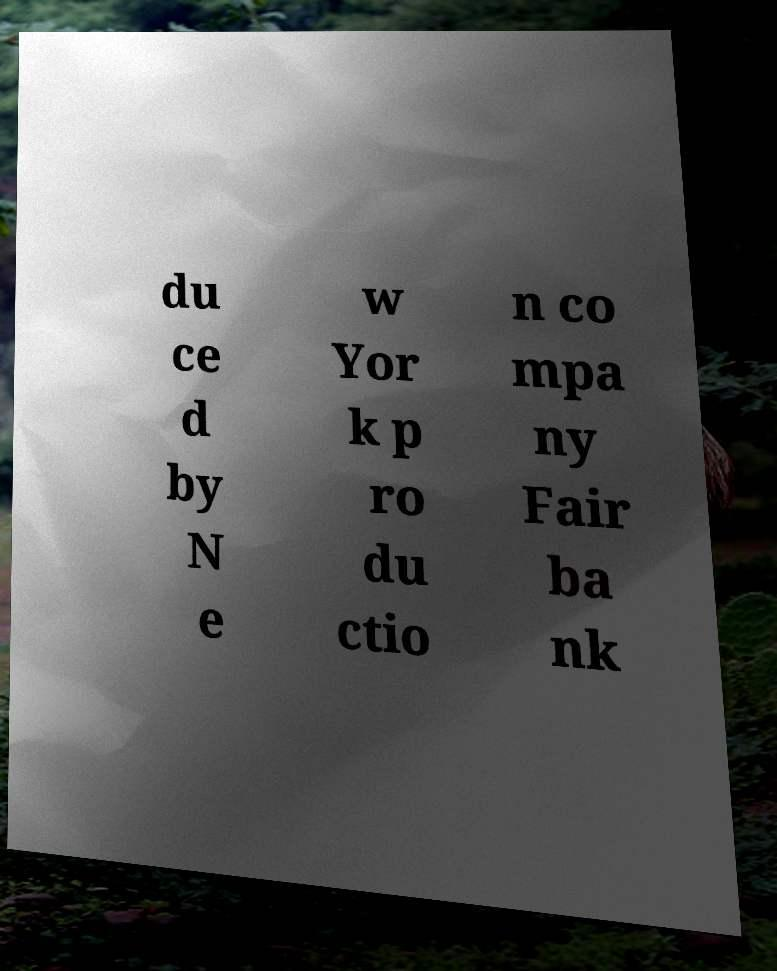What messages or text are displayed in this image? I need them in a readable, typed format. du ce d by N e w Yor k p ro du ctio n co mpa ny Fair ba nk 